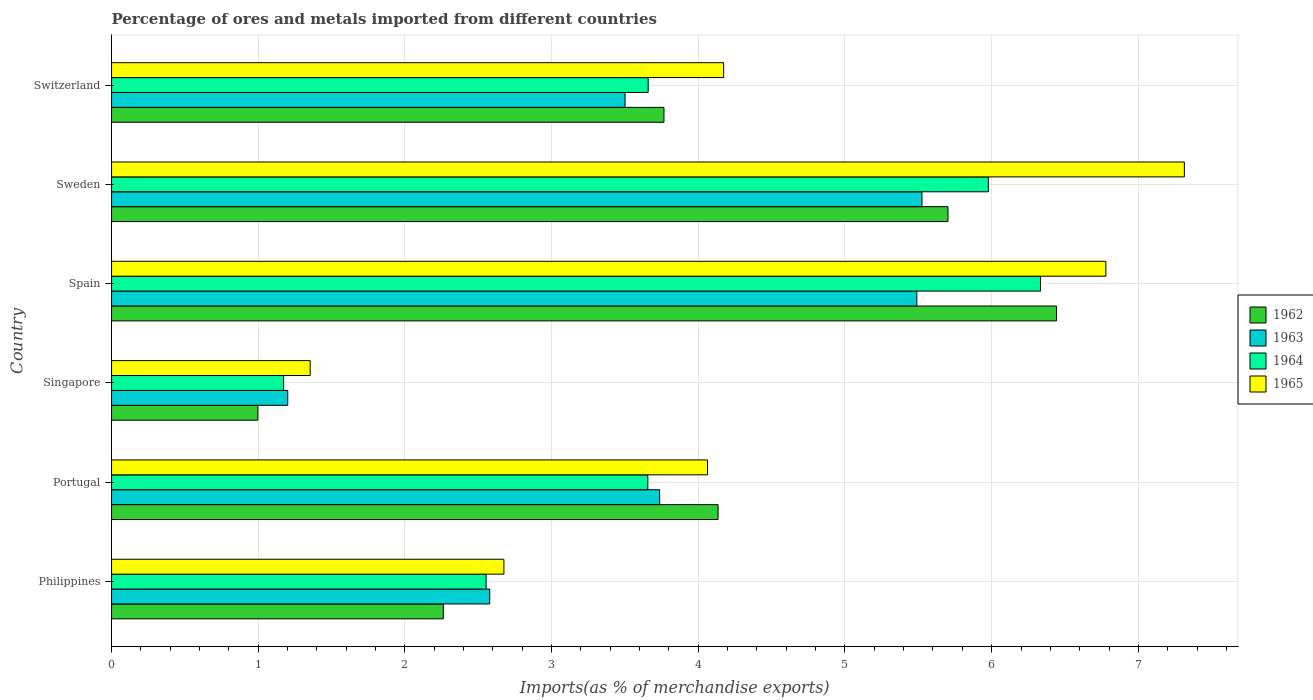How many different coloured bars are there?
Make the answer very short. 4. Are the number of bars per tick equal to the number of legend labels?
Your response must be concise. Yes. How many bars are there on the 4th tick from the top?
Offer a terse response. 4. How many bars are there on the 5th tick from the bottom?
Keep it short and to the point. 4. What is the label of the 1st group of bars from the top?
Offer a very short reply. Switzerland. In how many cases, is the number of bars for a given country not equal to the number of legend labels?
Ensure brevity in your answer.  0. What is the percentage of imports to different countries in 1962 in Switzerland?
Your response must be concise. 3.77. Across all countries, what is the maximum percentage of imports to different countries in 1965?
Offer a terse response. 7.31. Across all countries, what is the minimum percentage of imports to different countries in 1963?
Keep it short and to the point. 1.2. In which country was the percentage of imports to different countries in 1965 maximum?
Keep it short and to the point. Sweden. In which country was the percentage of imports to different countries in 1965 minimum?
Keep it short and to the point. Singapore. What is the total percentage of imports to different countries in 1963 in the graph?
Your answer should be compact. 22.03. What is the difference between the percentage of imports to different countries in 1964 in Sweden and that in Switzerland?
Make the answer very short. 2.32. What is the difference between the percentage of imports to different countries in 1962 in Portugal and the percentage of imports to different countries in 1964 in Philippines?
Your response must be concise. 1.58. What is the average percentage of imports to different countries in 1963 per country?
Your answer should be compact. 3.67. What is the difference between the percentage of imports to different countries in 1965 and percentage of imports to different countries in 1963 in Switzerland?
Offer a very short reply. 0.67. In how many countries, is the percentage of imports to different countries in 1964 greater than 2.4 %?
Offer a very short reply. 5. What is the ratio of the percentage of imports to different countries in 1965 in Portugal to that in Singapore?
Provide a short and direct response. 3. Is the percentage of imports to different countries in 1964 in Philippines less than that in Switzerland?
Give a very brief answer. Yes. Is the difference between the percentage of imports to different countries in 1965 in Portugal and Spain greater than the difference between the percentage of imports to different countries in 1963 in Portugal and Spain?
Give a very brief answer. No. What is the difference between the highest and the second highest percentage of imports to different countries in 1965?
Keep it short and to the point. 0.54. What is the difference between the highest and the lowest percentage of imports to different countries in 1964?
Offer a terse response. 5.16. In how many countries, is the percentage of imports to different countries in 1964 greater than the average percentage of imports to different countries in 1964 taken over all countries?
Provide a short and direct response. 2. What does the 1st bar from the top in Singapore represents?
Keep it short and to the point. 1965. How many bars are there?
Provide a succinct answer. 24. How many countries are there in the graph?
Your answer should be very brief. 6. Does the graph contain any zero values?
Offer a very short reply. No. Does the graph contain grids?
Provide a succinct answer. Yes. How many legend labels are there?
Offer a very short reply. 4. How are the legend labels stacked?
Make the answer very short. Vertical. What is the title of the graph?
Give a very brief answer. Percentage of ores and metals imported from different countries. What is the label or title of the X-axis?
Your answer should be compact. Imports(as % of merchandise exports). What is the Imports(as % of merchandise exports) of 1962 in Philippines?
Your answer should be very brief. 2.26. What is the Imports(as % of merchandise exports) of 1963 in Philippines?
Your answer should be compact. 2.58. What is the Imports(as % of merchandise exports) of 1964 in Philippines?
Offer a very short reply. 2.55. What is the Imports(as % of merchandise exports) of 1965 in Philippines?
Provide a short and direct response. 2.67. What is the Imports(as % of merchandise exports) in 1962 in Portugal?
Offer a terse response. 4.13. What is the Imports(as % of merchandise exports) in 1963 in Portugal?
Keep it short and to the point. 3.74. What is the Imports(as % of merchandise exports) of 1964 in Portugal?
Offer a very short reply. 3.66. What is the Imports(as % of merchandise exports) in 1965 in Portugal?
Provide a succinct answer. 4.06. What is the Imports(as % of merchandise exports) in 1962 in Singapore?
Make the answer very short. 1. What is the Imports(as % of merchandise exports) of 1963 in Singapore?
Your response must be concise. 1.2. What is the Imports(as % of merchandise exports) in 1964 in Singapore?
Provide a short and direct response. 1.17. What is the Imports(as % of merchandise exports) in 1965 in Singapore?
Give a very brief answer. 1.35. What is the Imports(as % of merchandise exports) in 1962 in Spain?
Offer a very short reply. 6.44. What is the Imports(as % of merchandise exports) of 1963 in Spain?
Offer a terse response. 5.49. What is the Imports(as % of merchandise exports) in 1964 in Spain?
Your answer should be very brief. 6.33. What is the Imports(as % of merchandise exports) in 1965 in Spain?
Your response must be concise. 6.78. What is the Imports(as % of merchandise exports) of 1962 in Sweden?
Ensure brevity in your answer.  5.7. What is the Imports(as % of merchandise exports) in 1963 in Sweden?
Make the answer very short. 5.52. What is the Imports(as % of merchandise exports) of 1964 in Sweden?
Your answer should be compact. 5.98. What is the Imports(as % of merchandise exports) of 1965 in Sweden?
Provide a succinct answer. 7.31. What is the Imports(as % of merchandise exports) of 1962 in Switzerland?
Your response must be concise. 3.77. What is the Imports(as % of merchandise exports) in 1963 in Switzerland?
Your response must be concise. 3.5. What is the Imports(as % of merchandise exports) in 1964 in Switzerland?
Give a very brief answer. 3.66. What is the Imports(as % of merchandise exports) of 1965 in Switzerland?
Your answer should be compact. 4.17. Across all countries, what is the maximum Imports(as % of merchandise exports) in 1962?
Your response must be concise. 6.44. Across all countries, what is the maximum Imports(as % of merchandise exports) of 1963?
Offer a very short reply. 5.52. Across all countries, what is the maximum Imports(as % of merchandise exports) in 1964?
Make the answer very short. 6.33. Across all countries, what is the maximum Imports(as % of merchandise exports) of 1965?
Keep it short and to the point. 7.31. Across all countries, what is the minimum Imports(as % of merchandise exports) of 1962?
Make the answer very short. 1. Across all countries, what is the minimum Imports(as % of merchandise exports) in 1963?
Keep it short and to the point. 1.2. Across all countries, what is the minimum Imports(as % of merchandise exports) of 1964?
Your answer should be very brief. 1.17. Across all countries, what is the minimum Imports(as % of merchandise exports) of 1965?
Keep it short and to the point. 1.35. What is the total Imports(as % of merchandise exports) of 1962 in the graph?
Provide a short and direct response. 23.3. What is the total Imports(as % of merchandise exports) in 1963 in the graph?
Your answer should be compact. 22.03. What is the total Imports(as % of merchandise exports) in 1964 in the graph?
Keep it short and to the point. 23.35. What is the total Imports(as % of merchandise exports) of 1965 in the graph?
Provide a succinct answer. 26.36. What is the difference between the Imports(as % of merchandise exports) in 1962 in Philippines and that in Portugal?
Keep it short and to the point. -1.87. What is the difference between the Imports(as % of merchandise exports) of 1963 in Philippines and that in Portugal?
Offer a terse response. -1.16. What is the difference between the Imports(as % of merchandise exports) in 1964 in Philippines and that in Portugal?
Your response must be concise. -1.1. What is the difference between the Imports(as % of merchandise exports) of 1965 in Philippines and that in Portugal?
Provide a succinct answer. -1.39. What is the difference between the Imports(as % of merchandise exports) of 1962 in Philippines and that in Singapore?
Offer a terse response. 1.26. What is the difference between the Imports(as % of merchandise exports) of 1963 in Philippines and that in Singapore?
Ensure brevity in your answer.  1.38. What is the difference between the Imports(as % of merchandise exports) in 1964 in Philippines and that in Singapore?
Your response must be concise. 1.38. What is the difference between the Imports(as % of merchandise exports) of 1965 in Philippines and that in Singapore?
Offer a very short reply. 1.32. What is the difference between the Imports(as % of merchandise exports) in 1962 in Philippines and that in Spain?
Give a very brief answer. -4.18. What is the difference between the Imports(as % of merchandise exports) of 1963 in Philippines and that in Spain?
Offer a very short reply. -2.91. What is the difference between the Imports(as % of merchandise exports) in 1964 in Philippines and that in Spain?
Keep it short and to the point. -3.78. What is the difference between the Imports(as % of merchandise exports) of 1965 in Philippines and that in Spain?
Offer a very short reply. -4.1. What is the difference between the Imports(as % of merchandise exports) in 1962 in Philippines and that in Sweden?
Ensure brevity in your answer.  -3.44. What is the difference between the Imports(as % of merchandise exports) in 1963 in Philippines and that in Sweden?
Provide a short and direct response. -2.95. What is the difference between the Imports(as % of merchandise exports) in 1964 in Philippines and that in Sweden?
Keep it short and to the point. -3.42. What is the difference between the Imports(as % of merchandise exports) of 1965 in Philippines and that in Sweden?
Your answer should be very brief. -4.64. What is the difference between the Imports(as % of merchandise exports) of 1962 in Philippines and that in Switzerland?
Provide a short and direct response. -1.5. What is the difference between the Imports(as % of merchandise exports) of 1963 in Philippines and that in Switzerland?
Offer a very short reply. -0.92. What is the difference between the Imports(as % of merchandise exports) in 1964 in Philippines and that in Switzerland?
Your answer should be compact. -1.1. What is the difference between the Imports(as % of merchandise exports) in 1965 in Philippines and that in Switzerland?
Offer a terse response. -1.5. What is the difference between the Imports(as % of merchandise exports) of 1962 in Portugal and that in Singapore?
Your answer should be compact. 3.14. What is the difference between the Imports(as % of merchandise exports) of 1963 in Portugal and that in Singapore?
Offer a terse response. 2.54. What is the difference between the Imports(as % of merchandise exports) of 1964 in Portugal and that in Singapore?
Provide a short and direct response. 2.48. What is the difference between the Imports(as % of merchandise exports) of 1965 in Portugal and that in Singapore?
Ensure brevity in your answer.  2.71. What is the difference between the Imports(as % of merchandise exports) of 1962 in Portugal and that in Spain?
Provide a succinct answer. -2.31. What is the difference between the Imports(as % of merchandise exports) of 1963 in Portugal and that in Spain?
Keep it short and to the point. -1.75. What is the difference between the Imports(as % of merchandise exports) of 1964 in Portugal and that in Spain?
Give a very brief answer. -2.68. What is the difference between the Imports(as % of merchandise exports) of 1965 in Portugal and that in Spain?
Keep it short and to the point. -2.72. What is the difference between the Imports(as % of merchandise exports) in 1962 in Portugal and that in Sweden?
Provide a succinct answer. -1.57. What is the difference between the Imports(as % of merchandise exports) of 1963 in Portugal and that in Sweden?
Offer a very short reply. -1.79. What is the difference between the Imports(as % of merchandise exports) in 1964 in Portugal and that in Sweden?
Ensure brevity in your answer.  -2.32. What is the difference between the Imports(as % of merchandise exports) in 1965 in Portugal and that in Sweden?
Make the answer very short. -3.25. What is the difference between the Imports(as % of merchandise exports) of 1962 in Portugal and that in Switzerland?
Your answer should be compact. 0.37. What is the difference between the Imports(as % of merchandise exports) in 1963 in Portugal and that in Switzerland?
Offer a very short reply. 0.24. What is the difference between the Imports(as % of merchandise exports) in 1964 in Portugal and that in Switzerland?
Your answer should be compact. -0. What is the difference between the Imports(as % of merchandise exports) of 1965 in Portugal and that in Switzerland?
Make the answer very short. -0.11. What is the difference between the Imports(as % of merchandise exports) of 1962 in Singapore and that in Spain?
Offer a terse response. -5.45. What is the difference between the Imports(as % of merchandise exports) in 1963 in Singapore and that in Spain?
Ensure brevity in your answer.  -4.29. What is the difference between the Imports(as % of merchandise exports) in 1964 in Singapore and that in Spain?
Ensure brevity in your answer.  -5.16. What is the difference between the Imports(as % of merchandise exports) in 1965 in Singapore and that in Spain?
Provide a short and direct response. -5.42. What is the difference between the Imports(as % of merchandise exports) of 1962 in Singapore and that in Sweden?
Keep it short and to the point. -4.7. What is the difference between the Imports(as % of merchandise exports) in 1963 in Singapore and that in Sweden?
Offer a terse response. -4.32. What is the difference between the Imports(as % of merchandise exports) in 1964 in Singapore and that in Sweden?
Make the answer very short. -4.8. What is the difference between the Imports(as % of merchandise exports) of 1965 in Singapore and that in Sweden?
Ensure brevity in your answer.  -5.96. What is the difference between the Imports(as % of merchandise exports) in 1962 in Singapore and that in Switzerland?
Your answer should be very brief. -2.77. What is the difference between the Imports(as % of merchandise exports) of 1963 in Singapore and that in Switzerland?
Provide a succinct answer. -2.3. What is the difference between the Imports(as % of merchandise exports) of 1964 in Singapore and that in Switzerland?
Give a very brief answer. -2.49. What is the difference between the Imports(as % of merchandise exports) in 1965 in Singapore and that in Switzerland?
Your answer should be very brief. -2.82. What is the difference between the Imports(as % of merchandise exports) of 1962 in Spain and that in Sweden?
Provide a succinct answer. 0.74. What is the difference between the Imports(as % of merchandise exports) of 1963 in Spain and that in Sweden?
Provide a succinct answer. -0.04. What is the difference between the Imports(as % of merchandise exports) of 1964 in Spain and that in Sweden?
Your answer should be compact. 0.36. What is the difference between the Imports(as % of merchandise exports) of 1965 in Spain and that in Sweden?
Your answer should be very brief. -0.54. What is the difference between the Imports(as % of merchandise exports) in 1962 in Spain and that in Switzerland?
Your answer should be very brief. 2.68. What is the difference between the Imports(as % of merchandise exports) in 1963 in Spain and that in Switzerland?
Your response must be concise. 1.99. What is the difference between the Imports(as % of merchandise exports) in 1964 in Spain and that in Switzerland?
Offer a terse response. 2.67. What is the difference between the Imports(as % of merchandise exports) of 1965 in Spain and that in Switzerland?
Give a very brief answer. 2.61. What is the difference between the Imports(as % of merchandise exports) in 1962 in Sweden and that in Switzerland?
Provide a short and direct response. 1.94. What is the difference between the Imports(as % of merchandise exports) of 1963 in Sweden and that in Switzerland?
Offer a terse response. 2.02. What is the difference between the Imports(as % of merchandise exports) in 1964 in Sweden and that in Switzerland?
Offer a very short reply. 2.32. What is the difference between the Imports(as % of merchandise exports) of 1965 in Sweden and that in Switzerland?
Offer a very short reply. 3.14. What is the difference between the Imports(as % of merchandise exports) of 1962 in Philippines and the Imports(as % of merchandise exports) of 1963 in Portugal?
Ensure brevity in your answer.  -1.47. What is the difference between the Imports(as % of merchandise exports) of 1962 in Philippines and the Imports(as % of merchandise exports) of 1964 in Portugal?
Provide a short and direct response. -1.39. What is the difference between the Imports(as % of merchandise exports) in 1962 in Philippines and the Imports(as % of merchandise exports) in 1965 in Portugal?
Keep it short and to the point. -1.8. What is the difference between the Imports(as % of merchandise exports) of 1963 in Philippines and the Imports(as % of merchandise exports) of 1964 in Portugal?
Ensure brevity in your answer.  -1.08. What is the difference between the Imports(as % of merchandise exports) in 1963 in Philippines and the Imports(as % of merchandise exports) in 1965 in Portugal?
Your response must be concise. -1.48. What is the difference between the Imports(as % of merchandise exports) in 1964 in Philippines and the Imports(as % of merchandise exports) in 1965 in Portugal?
Your response must be concise. -1.51. What is the difference between the Imports(as % of merchandise exports) of 1962 in Philippines and the Imports(as % of merchandise exports) of 1963 in Singapore?
Ensure brevity in your answer.  1.06. What is the difference between the Imports(as % of merchandise exports) in 1962 in Philippines and the Imports(as % of merchandise exports) in 1964 in Singapore?
Make the answer very short. 1.09. What is the difference between the Imports(as % of merchandise exports) in 1962 in Philippines and the Imports(as % of merchandise exports) in 1965 in Singapore?
Ensure brevity in your answer.  0.91. What is the difference between the Imports(as % of merchandise exports) in 1963 in Philippines and the Imports(as % of merchandise exports) in 1964 in Singapore?
Keep it short and to the point. 1.4. What is the difference between the Imports(as % of merchandise exports) in 1963 in Philippines and the Imports(as % of merchandise exports) in 1965 in Singapore?
Give a very brief answer. 1.22. What is the difference between the Imports(as % of merchandise exports) of 1964 in Philippines and the Imports(as % of merchandise exports) of 1965 in Singapore?
Offer a very short reply. 1.2. What is the difference between the Imports(as % of merchandise exports) of 1962 in Philippines and the Imports(as % of merchandise exports) of 1963 in Spain?
Your answer should be very brief. -3.23. What is the difference between the Imports(as % of merchandise exports) in 1962 in Philippines and the Imports(as % of merchandise exports) in 1964 in Spain?
Ensure brevity in your answer.  -4.07. What is the difference between the Imports(as % of merchandise exports) of 1962 in Philippines and the Imports(as % of merchandise exports) of 1965 in Spain?
Your response must be concise. -4.52. What is the difference between the Imports(as % of merchandise exports) in 1963 in Philippines and the Imports(as % of merchandise exports) in 1964 in Spain?
Ensure brevity in your answer.  -3.75. What is the difference between the Imports(as % of merchandise exports) of 1963 in Philippines and the Imports(as % of merchandise exports) of 1965 in Spain?
Ensure brevity in your answer.  -4.2. What is the difference between the Imports(as % of merchandise exports) of 1964 in Philippines and the Imports(as % of merchandise exports) of 1965 in Spain?
Offer a very short reply. -4.22. What is the difference between the Imports(as % of merchandise exports) of 1962 in Philippines and the Imports(as % of merchandise exports) of 1963 in Sweden?
Your answer should be very brief. -3.26. What is the difference between the Imports(as % of merchandise exports) in 1962 in Philippines and the Imports(as % of merchandise exports) in 1964 in Sweden?
Provide a short and direct response. -3.72. What is the difference between the Imports(as % of merchandise exports) of 1962 in Philippines and the Imports(as % of merchandise exports) of 1965 in Sweden?
Your answer should be compact. -5.05. What is the difference between the Imports(as % of merchandise exports) in 1963 in Philippines and the Imports(as % of merchandise exports) in 1964 in Sweden?
Make the answer very short. -3.4. What is the difference between the Imports(as % of merchandise exports) in 1963 in Philippines and the Imports(as % of merchandise exports) in 1965 in Sweden?
Your answer should be very brief. -4.74. What is the difference between the Imports(as % of merchandise exports) in 1964 in Philippines and the Imports(as % of merchandise exports) in 1965 in Sweden?
Offer a terse response. -4.76. What is the difference between the Imports(as % of merchandise exports) in 1962 in Philippines and the Imports(as % of merchandise exports) in 1963 in Switzerland?
Your answer should be very brief. -1.24. What is the difference between the Imports(as % of merchandise exports) in 1962 in Philippines and the Imports(as % of merchandise exports) in 1964 in Switzerland?
Keep it short and to the point. -1.4. What is the difference between the Imports(as % of merchandise exports) in 1962 in Philippines and the Imports(as % of merchandise exports) in 1965 in Switzerland?
Provide a succinct answer. -1.91. What is the difference between the Imports(as % of merchandise exports) in 1963 in Philippines and the Imports(as % of merchandise exports) in 1964 in Switzerland?
Provide a succinct answer. -1.08. What is the difference between the Imports(as % of merchandise exports) of 1963 in Philippines and the Imports(as % of merchandise exports) of 1965 in Switzerland?
Make the answer very short. -1.59. What is the difference between the Imports(as % of merchandise exports) of 1964 in Philippines and the Imports(as % of merchandise exports) of 1965 in Switzerland?
Provide a short and direct response. -1.62. What is the difference between the Imports(as % of merchandise exports) in 1962 in Portugal and the Imports(as % of merchandise exports) in 1963 in Singapore?
Provide a succinct answer. 2.93. What is the difference between the Imports(as % of merchandise exports) of 1962 in Portugal and the Imports(as % of merchandise exports) of 1964 in Singapore?
Offer a terse response. 2.96. What is the difference between the Imports(as % of merchandise exports) in 1962 in Portugal and the Imports(as % of merchandise exports) in 1965 in Singapore?
Give a very brief answer. 2.78. What is the difference between the Imports(as % of merchandise exports) of 1963 in Portugal and the Imports(as % of merchandise exports) of 1964 in Singapore?
Offer a terse response. 2.56. What is the difference between the Imports(as % of merchandise exports) of 1963 in Portugal and the Imports(as % of merchandise exports) of 1965 in Singapore?
Provide a short and direct response. 2.38. What is the difference between the Imports(as % of merchandise exports) of 1964 in Portugal and the Imports(as % of merchandise exports) of 1965 in Singapore?
Keep it short and to the point. 2.3. What is the difference between the Imports(as % of merchandise exports) in 1962 in Portugal and the Imports(as % of merchandise exports) in 1963 in Spain?
Your answer should be compact. -1.36. What is the difference between the Imports(as % of merchandise exports) of 1962 in Portugal and the Imports(as % of merchandise exports) of 1964 in Spain?
Your response must be concise. -2.2. What is the difference between the Imports(as % of merchandise exports) of 1962 in Portugal and the Imports(as % of merchandise exports) of 1965 in Spain?
Offer a very short reply. -2.64. What is the difference between the Imports(as % of merchandise exports) of 1963 in Portugal and the Imports(as % of merchandise exports) of 1964 in Spain?
Give a very brief answer. -2.6. What is the difference between the Imports(as % of merchandise exports) in 1963 in Portugal and the Imports(as % of merchandise exports) in 1965 in Spain?
Keep it short and to the point. -3.04. What is the difference between the Imports(as % of merchandise exports) of 1964 in Portugal and the Imports(as % of merchandise exports) of 1965 in Spain?
Your response must be concise. -3.12. What is the difference between the Imports(as % of merchandise exports) in 1962 in Portugal and the Imports(as % of merchandise exports) in 1963 in Sweden?
Provide a succinct answer. -1.39. What is the difference between the Imports(as % of merchandise exports) in 1962 in Portugal and the Imports(as % of merchandise exports) in 1964 in Sweden?
Your answer should be very brief. -1.84. What is the difference between the Imports(as % of merchandise exports) in 1962 in Portugal and the Imports(as % of merchandise exports) in 1965 in Sweden?
Provide a short and direct response. -3.18. What is the difference between the Imports(as % of merchandise exports) in 1963 in Portugal and the Imports(as % of merchandise exports) in 1964 in Sweden?
Your response must be concise. -2.24. What is the difference between the Imports(as % of merchandise exports) of 1963 in Portugal and the Imports(as % of merchandise exports) of 1965 in Sweden?
Provide a succinct answer. -3.58. What is the difference between the Imports(as % of merchandise exports) in 1964 in Portugal and the Imports(as % of merchandise exports) in 1965 in Sweden?
Give a very brief answer. -3.66. What is the difference between the Imports(as % of merchandise exports) in 1962 in Portugal and the Imports(as % of merchandise exports) in 1963 in Switzerland?
Offer a very short reply. 0.63. What is the difference between the Imports(as % of merchandise exports) of 1962 in Portugal and the Imports(as % of merchandise exports) of 1964 in Switzerland?
Your response must be concise. 0.48. What is the difference between the Imports(as % of merchandise exports) in 1962 in Portugal and the Imports(as % of merchandise exports) in 1965 in Switzerland?
Ensure brevity in your answer.  -0.04. What is the difference between the Imports(as % of merchandise exports) in 1963 in Portugal and the Imports(as % of merchandise exports) in 1964 in Switzerland?
Make the answer very short. 0.08. What is the difference between the Imports(as % of merchandise exports) of 1963 in Portugal and the Imports(as % of merchandise exports) of 1965 in Switzerland?
Your answer should be very brief. -0.44. What is the difference between the Imports(as % of merchandise exports) of 1964 in Portugal and the Imports(as % of merchandise exports) of 1965 in Switzerland?
Your response must be concise. -0.52. What is the difference between the Imports(as % of merchandise exports) of 1962 in Singapore and the Imports(as % of merchandise exports) of 1963 in Spain?
Your answer should be very brief. -4.49. What is the difference between the Imports(as % of merchandise exports) of 1962 in Singapore and the Imports(as % of merchandise exports) of 1964 in Spain?
Provide a succinct answer. -5.34. What is the difference between the Imports(as % of merchandise exports) in 1962 in Singapore and the Imports(as % of merchandise exports) in 1965 in Spain?
Your response must be concise. -5.78. What is the difference between the Imports(as % of merchandise exports) of 1963 in Singapore and the Imports(as % of merchandise exports) of 1964 in Spain?
Your answer should be very brief. -5.13. What is the difference between the Imports(as % of merchandise exports) in 1963 in Singapore and the Imports(as % of merchandise exports) in 1965 in Spain?
Make the answer very short. -5.58. What is the difference between the Imports(as % of merchandise exports) of 1964 in Singapore and the Imports(as % of merchandise exports) of 1965 in Spain?
Offer a very short reply. -5.61. What is the difference between the Imports(as % of merchandise exports) of 1962 in Singapore and the Imports(as % of merchandise exports) of 1963 in Sweden?
Offer a very short reply. -4.53. What is the difference between the Imports(as % of merchandise exports) in 1962 in Singapore and the Imports(as % of merchandise exports) in 1964 in Sweden?
Provide a short and direct response. -4.98. What is the difference between the Imports(as % of merchandise exports) in 1962 in Singapore and the Imports(as % of merchandise exports) in 1965 in Sweden?
Give a very brief answer. -6.32. What is the difference between the Imports(as % of merchandise exports) of 1963 in Singapore and the Imports(as % of merchandise exports) of 1964 in Sweden?
Make the answer very short. -4.78. What is the difference between the Imports(as % of merchandise exports) of 1963 in Singapore and the Imports(as % of merchandise exports) of 1965 in Sweden?
Make the answer very short. -6.11. What is the difference between the Imports(as % of merchandise exports) of 1964 in Singapore and the Imports(as % of merchandise exports) of 1965 in Sweden?
Your answer should be compact. -6.14. What is the difference between the Imports(as % of merchandise exports) in 1962 in Singapore and the Imports(as % of merchandise exports) in 1963 in Switzerland?
Your answer should be very brief. -2.5. What is the difference between the Imports(as % of merchandise exports) in 1962 in Singapore and the Imports(as % of merchandise exports) in 1964 in Switzerland?
Offer a very short reply. -2.66. What is the difference between the Imports(as % of merchandise exports) in 1962 in Singapore and the Imports(as % of merchandise exports) in 1965 in Switzerland?
Your answer should be compact. -3.18. What is the difference between the Imports(as % of merchandise exports) in 1963 in Singapore and the Imports(as % of merchandise exports) in 1964 in Switzerland?
Keep it short and to the point. -2.46. What is the difference between the Imports(as % of merchandise exports) in 1963 in Singapore and the Imports(as % of merchandise exports) in 1965 in Switzerland?
Make the answer very short. -2.97. What is the difference between the Imports(as % of merchandise exports) in 1964 in Singapore and the Imports(as % of merchandise exports) in 1965 in Switzerland?
Make the answer very short. -3. What is the difference between the Imports(as % of merchandise exports) in 1962 in Spain and the Imports(as % of merchandise exports) in 1963 in Sweden?
Keep it short and to the point. 0.92. What is the difference between the Imports(as % of merchandise exports) of 1962 in Spain and the Imports(as % of merchandise exports) of 1964 in Sweden?
Ensure brevity in your answer.  0.47. What is the difference between the Imports(as % of merchandise exports) of 1962 in Spain and the Imports(as % of merchandise exports) of 1965 in Sweden?
Ensure brevity in your answer.  -0.87. What is the difference between the Imports(as % of merchandise exports) of 1963 in Spain and the Imports(as % of merchandise exports) of 1964 in Sweden?
Your answer should be very brief. -0.49. What is the difference between the Imports(as % of merchandise exports) of 1963 in Spain and the Imports(as % of merchandise exports) of 1965 in Sweden?
Your response must be concise. -1.82. What is the difference between the Imports(as % of merchandise exports) in 1964 in Spain and the Imports(as % of merchandise exports) in 1965 in Sweden?
Your response must be concise. -0.98. What is the difference between the Imports(as % of merchandise exports) in 1962 in Spain and the Imports(as % of merchandise exports) in 1963 in Switzerland?
Provide a short and direct response. 2.94. What is the difference between the Imports(as % of merchandise exports) in 1962 in Spain and the Imports(as % of merchandise exports) in 1964 in Switzerland?
Make the answer very short. 2.78. What is the difference between the Imports(as % of merchandise exports) of 1962 in Spain and the Imports(as % of merchandise exports) of 1965 in Switzerland?
Offer a very short reply. 2.27. What is the difference between the Imports(as % of merchandise exports) of 1963 in Spain and the Imports(as % of merchandise exports) of 1964 in Switzerland?
Keep it short and to the point. 1.83. What is the difference between the Imports(as % of merchandise exports) in 1963 in Spain and the Imports(as % of merchandise exports) in 1965 in Switzerland?
Keep it short and to the point. 1.32. What is the difference between the Imports(as % of merchandise exports) of 1964 in Spain and the Imports(as % of merchandise exports) of 1965 in Switzerland?
Your answer should be compact. 2.16. What is the difference between the Imports(as % of merchandise exports) of 1962 in Sweden and the Imports(as % of merchandise exports) of 1963 in Switzerland?
Offer a terse response. 2.2. What is the difference between the Imports(as % of merchandise exports) in 1962 in Sweden and the Imports(as % of merchandise exports) in 1964 in Switzerland?
Your answer should be very brief. 2.04. What is the difference between the Imports(as % of merchandise exports) in 1962 in Sweden and the Imports(as % of merchandise exports) in 1965 in Switzerland?
Offer a very short reply. 1.53. What is the difference between the Imports(as % of merchandise exports) of 1963 in Sweden and the Imports(as % of merchandise exports) of 1964 in Switzerland?
Give a very brief answer. 1.87. What is the difference between the Imports(as % of merchandise exports) of 1963 in Sweden and the Imports(as % of merchandise exports) of 1965 in Switzerland?
Your answer should be compact. 1.35. What is the difference between the Imports(as % of merchandise exports) of 1964 in Sweden and the Imports(as % of merchandise exports) of 1965 in Switzerland?
Provide a succinct answer. 1.8. What is the average Imports(as % of merchandise exports) in 1962 per country?
Offer a terse response. 3.88. What is the average Imports(as % of merchandise exports) of 1963 per country?
Offer a terse response. 3.67. What is the average Imports(as % of merchandise exports) of 1964 per country?
Your answer should be very brief. 3.89. What is the average Imports(as % of merchandise exports) in 1965 per country?
Ensure brevity in your answer.  4.39. What is the difference between the Imports(as % of merchandise exports) of 1962 and Imports(as % of merchandise exports) of 1963 in Philippines?
Make the answer very short. -0.32. What is the difference between the Imports(as % of merchandise exports) in 1962 and Imports(as % of merchandise exports) in 1964 in Philippines?
Make the answer very short. -0.29. What is the difference between the Imports(as % of merchandise exports) in 1962 and Imports(as % of merchandise exports) in 1965 in Philippines?
Your answer should be compact. -0.41. What is the difference between the Imports(as % of merchandise exports) in 1963 and Imports(as % of merchandise exports) in 1964 in Philippines?
Your response must be concise. 0.02. What is the difference between the Imports(as % of merchandise exports) of 1963 and Imports(as % of merchandise exports) of 1965 in Philippines?
Give a very brief answer. -0.1. What is the difference between the Imports(as % of merchandise exports) of 1964 and Imports(as % of merchandise exports) of 1965 in Philippines?
Offer a terse response. -0.12. What is the difference between the Imports(as % of merchandise exports) of 1962 and Imports(as % of merchandise exports) of 1963 in Portugal?
Your response must be concise. 0.4. What is the difference between the Imports(as % of merchandise exports) in 1962 and Imports(as % of merchandise exports) in 1964 in Portugal?
Provide a short and direct response. 0.48. What is the difference between the Imports(as % of merchandise exports) of 1962 and Imports(as % of merchandise exports) of 1965 in Portugal?
Make the answer very short. 0.07. What is the difference between the Imports(as % of merchandise exports) of 1963 and Imports(as % of merchandise exports) of 1964 in Portugal?
Ensure brevity in your answer.  0.08. What is the difference between the Imports(as % of merchandise exports) in 1963 and Imports(as % of merchandise exports) in 1965 in Portugal?
Give a very brief answer. -0.33. What is the difference between the Imports(as % of merchandise exports) in 1964 and Imports(as % of merchandise exports) in 1965 in Portugal?
Your answer should be compact. -0.41. What is the difference between the Imports(as % of merchandise exports) in 1962 and Imports(as % of merchandise exports) in 1963 in Singapore?
Your response must be concise. -0.2. What is the difference between the Imports(as % of merchandise exports) in 1962 and Imports(as % of merchandise exports) in 1964 in Singapore?
Provide a short and direct response. -0.18. What is the difference between the Imports(as % of merchandise exports) of 1962 and Imports(as % of merchandise exports) of 1965 in Singapore?
Your response must be concise. -0.36. What is the difference between the Imports(as % of merchandise exports) in 1963 and Imports(as % of merchandise exports) in 1964 in Singapore?
Your answer should be compact. 0.03. What is the difference between the Imports(as % of merchandise exports) in 1963 and Imports(as % of merchandise exports) in 1965 in Singapore?
Your answer should be very brief. -0.15. What is the difference between the Imports(as % of merchandise exports) in 1964 and Imports(as % of merchandise exports) in 1965 in Singapore?
Provide a succinct answer. -0.18. What is the difference between the Imports(as % of merchandise exports) in 1962 and Imports(as % of merchandise exports) in 1964 in Spain?
Offer a very short reply. 0.11. What is the difference between the Imports(as % of merchandise exports) of 1962 and Imports(as % of merchandise exports) of 1965 in Spain?
Your response must be concise. -0.34. What is the difference between the Imports(as % of merchandise exports) in 1963 and Imports(as % of merchandise exports) in 1964 in Spain?
Ensure brevity in your answer.  -0.84. What is the difference between the Imports(as % of merchandise exports) in 1963 and Imports(as % of merchandise exports) in 1965 in Spain?
Offer a very short reply. -1.29. What is the difference between the Imports(as % of merchandise exports) of 1964 and Imports(as % of merchandise exports) of 1965 in Spain?
Make the answer very short. -0.45. What is the difference between the Imports(as % of merchandise exports) in 1962 and Imports(as % of merchandise exports) in 1963 in Sweden?
Keep it short and to the point. 0.18. What is the difference between the Imports(as % of merchandise exports) of 1962 and Imports(as % of merchandise exports) of 1964 in Sweden?
Offer a very short reply. -0.28. What is the difference between the Imports(as % of merchandise exports) of 1962 and Imports(as % of merchandise exports) of 1965 in Sweden?
Keep it short and to the point. -1.61. What is the difference between the Imports(as % of merchandise exports) of 1963 and Imports(as % of merchandise exports) of 1964 in Sweden?
Your answer should be very brief. -0.45. What is the difference between the Imports(as % of merchandise exports) of 1963 and Imports(as % of merchandise exports) of 1965 in Sweden?
Offer a very short reply. -1.79. What is the difference between the Imports(as % of merchandise exports) in 1964 and Imports(as % of merchandise exports) in 1965 in Sweden?
Keep it short and to the point. -1.34. What is the difference between the Imports(as % of merchandise exports) of 1962 and Imports(as % of merchandise exports) of 1963 in Switzerland?
Ensure brevity in your answer.  0.27. What is the difference between the Imports(as % of merchandise exports) in 1962 and Imports(as % of merchandise exports) in 1964 in Switzerland?
Offer a very short reply. 0.11. What is the difference between the Imports(as % of merchandise exports) of 1962 and Imports(as % of merchandise exports) of 1965 in Switzerland?
Your response must be concise. -0.41. What is the difference between the Imports(as % of merchandise exports) in 1963 and Imports(as % of merchandise exports) in 1964 in Switzerland?
Keep it short and to the point. -0.16. What is the difference between the Imports(as % of merchandise exports) of 1963 and Imports(as % of merchandise exports) of 1965 in Switzerland?
Your answer should be very brief. -0.67. What is the difference between the Imports(as % of merchandise exports) in 1964 and Imports(as % of merchandise exports) in 1965 in Switzerland?
Offer a very short reply. -0.51. What is the ratio of the Imports(as % of merchandise exports) in 1962 in Philippines to that in Portugal?
Offer a terse response. 0.55. What is the ratio of the Imports(as % of merchandise exports) in 1963 in Philippines to that in Portugal?
Make the answer very short. 0.69. What is the ratio of the Imports(as % of merchandise exports) of 1964 in Philippines to that in Portugal?
Offer a terse response. 0.7. What is the ratio of the Imports(as % of merchandise exports) in 1965 in Philippines to that in Portugal?
Your answer should be compact. 0.66. What is the ratio of the Imports(as % of merchandise exports) in 1962 in Philippines to that in Singapore?
Provide a succinct answer. 2.27. What is the ratio of the Imports(as % of merchandise exports) in 1963 in Philippines to that in Singapore?
Keep it short and to the point. 2.15. What is the ratio of the Imports(as % of merchandise exports) of 1964 in Philippines to that in Singapore?
Keep it short and to the point. 2.18. What is the ratio of the Imports(as % of merchandise exports) of 1965 in Philippines to that in Singapore?
Your answer should be compact. 1.98. What is the ratio of the Imports(as % of merchandise exports) in 1962 in Philippines to that in Spain?
Provide a short and direct response. 0.35. What is the ratio of the Imports(as % of merchandise exports) in 1963 in Philippines to that in Spain?
Your response must be concise. 0.47. What is the ratio of the Imports(as % of merchandise exports) in 1964 in Philippines to that in Spain?
Ensure brevity in your answer.  0.4. What is the ratio of the Imports(as % of merchandise exports) of 1965 in Philippines to that in Spain?
Make the answer very short. 0.39. What is the ratio of the Imports(as % of merchandise exports) of 1962 in Philippines to that in Sweden?
Ensure brevity in your answer.  0.4. What is the ratio of the Imports(as % of merchandise exports) of 1963 in Philippines to that in Sweden?
Give a very brief answer. 0.47. What is the ratio of the Imports(as % of merchandise exports) of 1964 in Philippines to that in Sweden?
Your answer should be compact. 0.43. What is the ratio of the Imports(as % of merchandise exports) in 1965 in Philippines to that in Sweden?
Your answer should be compact. 0.37. What is the ratio of the Imports(as % of merchandise exports) in 1962 in Philippines to that in Switzerland?
Give a very brief answer. 0.6. What is the ratio of the Imports(as % of merchandise exports) of 1963 in Philippines to that in Switzerland?
Make the answer very short. 0.74. What is the ratio of the Imports(as % of merchandise exports) of 1964 in Philippines to that in Switzerland?
Ensure brevity in your answer.  0.7. What is the ratio of the Imports(as % of merchandise exports) in 1965 in Philippines to that in Switzerland?
Your response must be concise. 0.64. What is the ratio of the Imports(as % of merchandise exports) in 1962 in Portugal to that in Singapore?
Provide a short and direct response. 4.15. What is the ratio of the Imports(as % of merchandise exports) in 1963 in Portugal to that in Singapore?
Keep it short and to the point. 3.11. What is the ratio of the Imports(as % of merchandise exports) of 1964 in Portugal to that in Singapore?
Ensure brevity in your answer.  3.12. What is the ratio of the Imports(as % of merchandise exports) of 1965 in Portugal to that in Singapore?
Offer a very short reply. 3. What is the ratio of the Imports(as % of merchandise exports) of 1962 in Portugal to that in Spain?
Keep it short and to the point. 0.64. What is the ratio of the Imports(as % of merchandise exports) in 1963 in Portugal to that in Spain?
Offer a very short reply. 0.68. What is the ratio of the Imports(as % of merchandise exports) in 1964 in Portugal to that in Spain?
Keep it short and to the point. 0.58. What is the ratio of the Imports(as % of merchandise exports) in 1965 in Portugal to that in Spain?
Offer a terse response. 0.6. What is the ratio of the Imports(as % of merchandise exports) of 1962 in Portugal to that in Sweden?
Make the answer very short. 0.73. What is the ratio of the Imports(as % of merchandise exports) in 1963 in Portugal to that in Sweden?
Make the answer very short. 0.68. What is the ratio of the Imports(as % of merchandise exports) of 1964 in Portugal to that in Sweden?
Your answer should be very brief. 0.61. What is the ratio of the Imports(as % of merchandise exports) of 1965 in Portugal to that in Sweden?
Give a very brief answer. 0.56. What is the ratio of the Imports(as % of merchandise exports) of 1962 in Portugal to that in Switzerland?
Give a very brief answer. 1.1. What is the ratio of the Imports(as % of merchandise exports) in 1963 in Portugal to that in Switzerland?
Make the answer very short. 1.07. What is the ratio of the Imports(as % of merchandise exports) in 1964 in Portugal to that in Switzerland?
Provide a succinct answer. 1. What is the ratio of the Imports(as % of merchandise exports) in 1965 in Portugal to that in Switzerland?
Your answer should be very brief. 0.97. What is the ratio of the Imports(as % of merchandise exports) of 1962 in Singapore to that in Spain?
Your answer should be compact. 0.15. What is the ratio of the Imports(as % of merchandise exports) of 1963 in Singapore to that in Spain?
Make the answer very short. 0.22. What is the ratio of the Imports(as % of merchandise exports) in 1964 in Singapore to that in Spain?
Keep it short and to the point. 0.19. What is the ratio of the Imports(as % of merchandise exports) in 1965 in Singapore to that in Spain?
Keep it short and to the point. 0.2. What is the ratio of the Imports(as % of merchandise exports) in 1962 in Singapore to that in Sweden?
Make the answer very short. 0.17. What is the ratio of the Imports(as % of merchandise exports) in 1963 in Singapore to that in Sweden?
Offer a terse response. 0.22. What is the ratio of the Imports(as % of merchandise exports) of 1964 in Singapore to that in Sweden?
Keep it short and to the point. 0.2. What is the ratio of the Imports(as % of merchandise exports) in 1965 in Singapore to that in Sweden?
Keep it short and to the point. 0.19. What is the ratio of the Imports(as % of merchandise exports) in 1962 in Singapore to that in Switzerland?
Offer a very short reply. 0.26. What is the ratio of the Imports(as % of merchandise exports) in 1963 in Singapore to that in Switzerland?
Make the answer very short. 0.34. What is the ratio of the Imports(as % of merchandise exports) of 1964 in Singapore to that in Switzerland?
Give a very brief answer. 0.32. What is the ratio of the Imports(as % of merchandise exports) of 1965 in Singapore to that in Switzerland?
Provide a short and direct response. 0.32. What is the ratio of the Imports(as % of merchandise exports) in 1962 in Spain to that in Sweden?
Make the answer very short. 1.13. What is the ratio of the Imports(as % of merchandise exports) of 1964 in Spain to that in Sweden?
Your response must be concise. 1.06. What is the ratio of the Imports(as % of merchandise exports) of 1965 in Spain to that in Sweden?
Keep it short and to the point. 0.93. What is the ratio of the Imports(as % of merchandise exports) of 1962 in Spain to that in Switzerland?
Provide a succinct answer. 1.71. What is the ratio of the Imports(as % of merchandise exports) in 1963 in Spain to that in Switzerland?
Give a very brief answer. 1.57. What is the ratio of the Imports(as % of merchandise exports) of 1964 in Spain to that in Switzerland?
Give a very brief answer. 1.73. What is the ratio of the Imports(as % of merchandise exports) of 1965 in Spain to that in Switzerland?
Provide a short and direct response. 1.62. What is the ratio of the Imports(as % of merchandise exports) of 1962 in Sweden to that in Switzerland?
Offer a terse response. 1.51. What is the ratio of the Imports(as % of merchandise exports) of 1963 in Sweden to that in Switzerland?
Offer a very short reply. 1.58. What is the ratio of the Imports(as % of merchandise exports) of 1964 in Sweden to that in Switzerland?
Make the answer very short. 1.63. What is the ratio of the Imports(as % of merchandise exports) of 1965 in Sweden to that in Switzerland?
Your response must be concise. 1.75. What is the difference between the highest and the second highest Imports(as % of merchandise exports) in 1962?
Give a very brief answer. 0.74. What is the difference between the highest and the second highest Imports(as % of merchandise exports) in 1963?
Provide a short and direct response. 0.04. What is the difference between the highest and the second highest Imports(as % of merchandise exports) of 1964?
Your answer should be very brief. 0.36. What is the difference between the highest and the second highest Imports(as % of merchandise exports) in 1965?
Ensure brevity in your answer.  0.54. What is the difference between the highest and the lowest Imports(as % of merchandise exports) of 1962?
Your answer should be very brief. 5.45. What is the difference between the highest and the lowest Imports(as % of merchandise exports) of 1963?
Provide a short and direct response. 4.32. What is the difference between the highest and the lowest Imports(as % of merchandise exports) in 1964?
Your answer should be compact. 5.16. What is the difference between the highest and the lowest Imports(as % of merchandise exports) in 1965?
Your answer should be very brief. 5.96. 